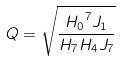Convert formula to latex. <formula><loc_0><loc_0><loc_500><loc_500>Q = \sqrt { \frac { { H _ { 0 } } ^ { 7 } J _ { 1 } } { H _ { 7 } H _ { 4 } J _ { 7 } } }</formula> 